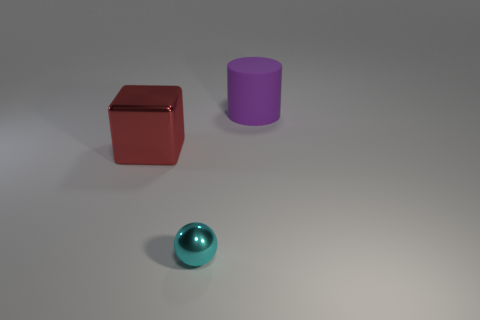Add 3 small cyan metallic things. How many objects exist? 6 Subtract all cylinders. How many objects are left? 2 Subtract all small rubber spheres. Subtract all red shiny objects. How many objects are left? 2 Add 1 small shiny objects. How many small shiny objects are left? 2 Add 2 gray rubber objects. How many gray rubber objects exist? 2 Subtract 1 red blocks. How many objects are left? 2 Subtract 1 blocks. How many blocks are left? 0 Subtract all purple spheres. How many brown blocks are left? 0 